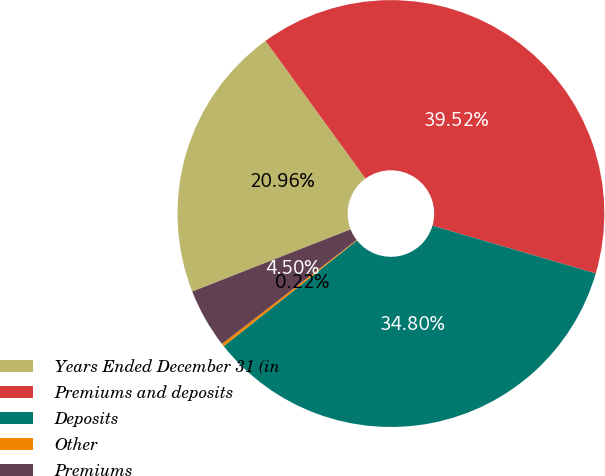Convert chart. <chart><loc_0><loc_0><loc_500><loc_500><pie_chart><fcel>Years Ended December 31 (in<fcel>Premiums and deposits<fcel>Deposits<fcel>Other<fcel>Premiums<nl><fcel>20.96%<fcel>39.52%<fcel>34.8%<fcel>0.22%<fcel>4.5%<nl></chart> 